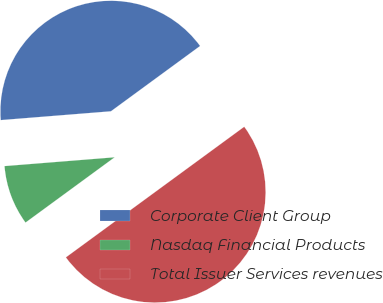Convert chart to OTSL. <chart><loc_0><loc_0><loc_500><loc_500><pie_chart><fcel>Corporate Client Group<fcel>Nasdaq Financial Products<fcel>Total Issuer Services revenues<nl><fcel>41.21%<fcel>8.79%<fcel>50.0%<nl></chart> 